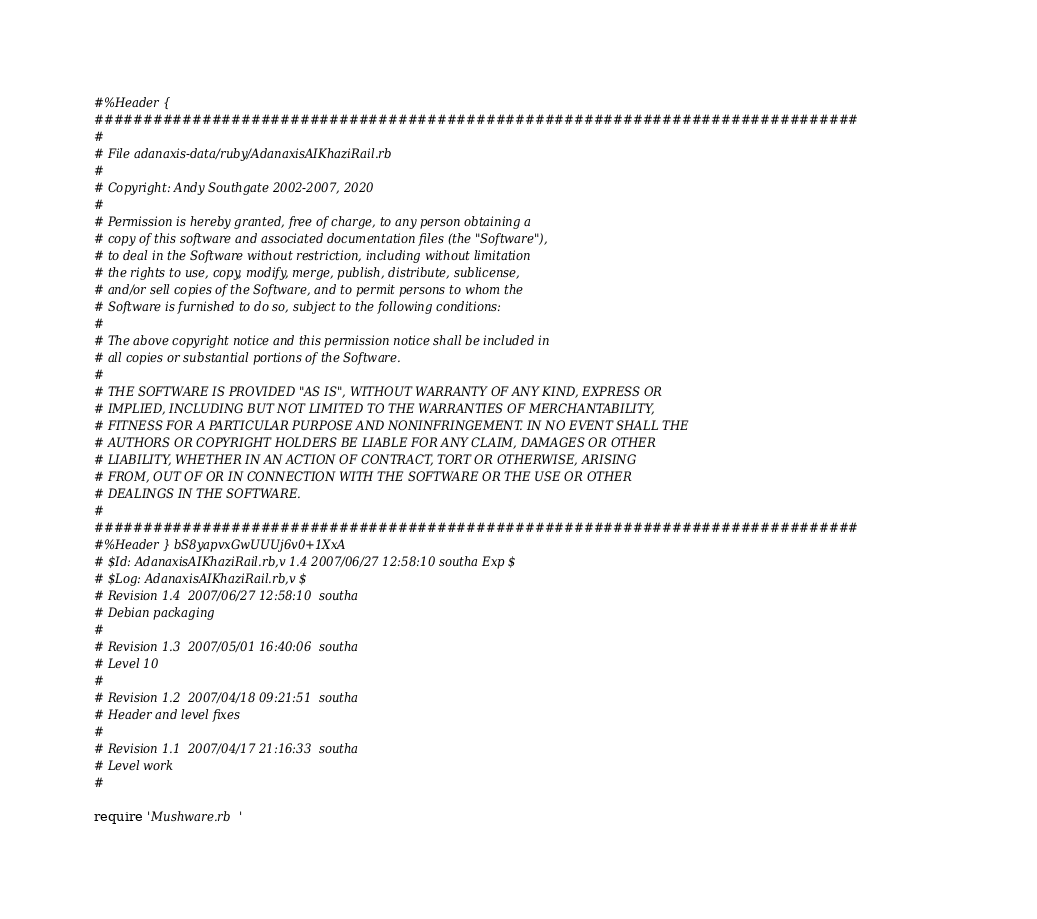Convert code to text. <code><loc_0><loc_0><loc_500><loc_500><_Ruby_>#%Header {
##############################################################################
#
# File adanaxis-data/ruby/AdanaxisAIKhaziRail.rb
#
# Copyright: Andy Southgate 2002-2007, 2020
#
# Permission is hereby granted, free of charge, to any person obtaining a
# copy of this software and associated documentation files (the "Software"),
# to deal in the Software without restriction, including without limitation
# the rights to use, copy, modify, merge, publish, distribute, sublicense,
# and/or sell copies of the Software, and to permit persons to whom the
# Software is furnished to do so, subject to the following conditions:
#
# The above copyright notice and this permission notice shall be included in
# all copies or substantial portions of the Software.
#
# THE SOFTWARE IS PROVIDED "AS IS", WITHOUT WARRANTY OF ANY KIND, EXPRESS OR
# IMPLIED, INCLUDING BUT NOT LIMITED TO THE WARRANTIES OF MERCHANTABILITY,
# FITNESS FOR A PARTICULAR PURPOSE AND NONINFRINGEMENT. IN NO EVENT SHALL THE
# AUTHORS OR COPYRIGHT HOLDERS BE LIABLE FOR ANY CLAIM, DAMAGES OR OTHER
# LIABILITY, WHETHER IN AN ACTION OF CONTRACT, TORT OR OTHERWISE, ARISING
# FROM, OUT OF OR IN CONNECTION WITH THE SOFTWARE OR THE USE OR OTHER
# DEALINGS IN THE SOFTWARE.
#
##############################################################################
#%Header } bS8yapvxGwUUUj6v0+1XxA
# $Id: AdanaxisAIKhaziRail.rb,v 1.4 2007/06/27 12:58:10 southa Exp $
# $Log: AdanaxisAIKhaziRail.rb,v $
# Revision 1.4  2007/06/27 12:58:10  southa
# Debian packaging
#
# Revision 1.3  2007/05/01 16:40:06  southa
# Level 10
#
# Revision 1.2  2007/04/18 09:21:51  southa
# Header and level fixes
#
# Revision 1.1  2007/04/17 21:16:33  southa
# Level work
#

require 'Mushware.rb'</code> 